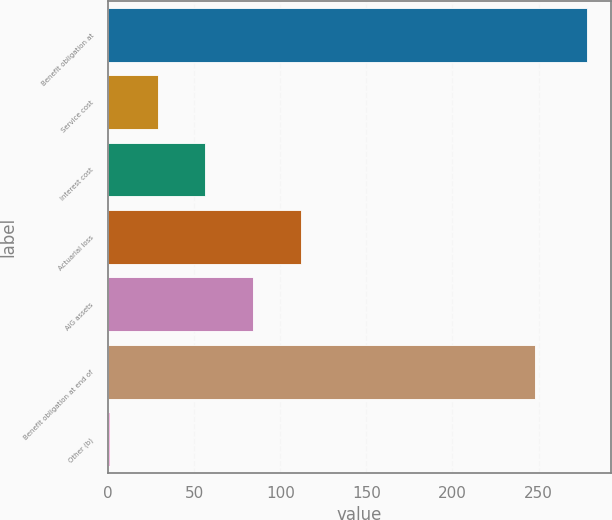Convert chart. <chart><loc_0><loc_0><loc_500><loc_500><bar_chart><fcel>Benefit obligation at<fcel>Service cost<fcel>Interest cost<fcel>Actuarial loss<fcel>AIG assets<fcel>Benefit obligation at end of<fcel>Other (b)<nl><fcel>278<fcel>28.7<fcel>56.4<fcel>111.8<fcel>84.1<fcel>248<fcel>1<nl></chart> 